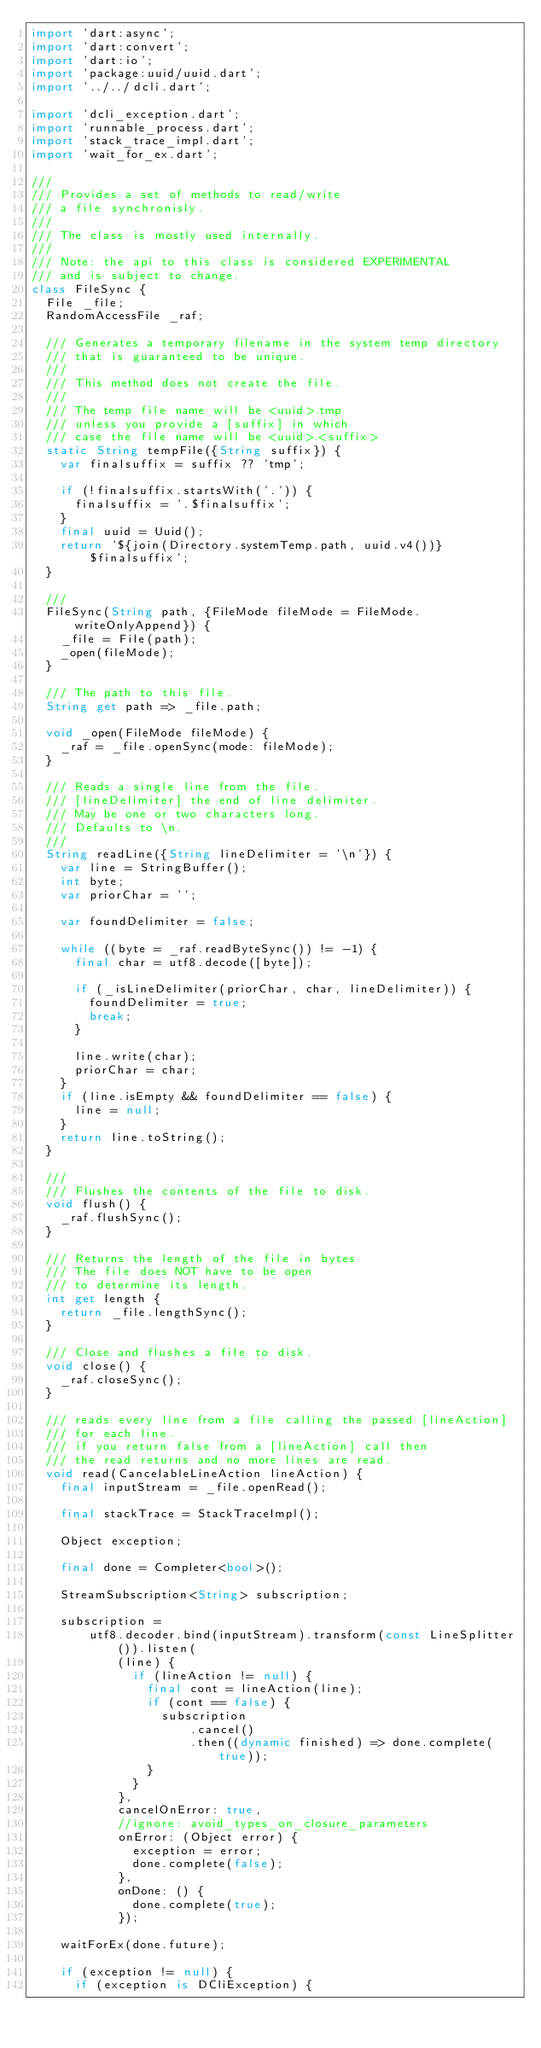<code> <loc_0><loc_0><loc_500><loc_500><_Dart_>import 'dart:async';
import 'dart:convert';
import 'dart:io';
import 'package:uuid/uuid.dart';
import '../../dcli.dart';

import 'dcli_exception.dart';
import 'runnable_process.dart';
import 'stack_trace_impl.dart';
import 'wait_for_ex.dart';

///
/// Provides a set of methods to read/write
/// a file synchronisly.
///
/// The class is mostly used internally.
///
/// Note: the api to this class is considered EXPERIMENTAL
/// and is subject to change.
class FileSync {
  File _file;
  RandomAccessFile _raf;

  /// Generates a temporary filename in the system temp directory
  /// that is guaranteed to be unique.
  ///
  /// This method does not create the file.
  ///
  /// The temp file name will be <uuid>.tmp
  /// unless you provide a [suffix] in which
  /// case the file name will be <uuid>.<suffix>
  static String tempFile({String suffix}) {
    var finalsuffix = suffix ?? 'tmp';

    if (!finalsuffix.startsWith('.')) {
      finalsuffix = '.$finalsuffix';
    }
    final uuid = Uuid();
    return '${join(Directory.systemTemp.path, uuid.v4())}$finalsuffix';
  }

  ///
  FileSync(String path, {FileMode fileMode = FileMode.writeOnlyAppend}) {
    _file = File(path);
    _open(fileMode);
  }

  /// The path to this file.
  String get path => _file.path;

  void _open(FileMode fileMode) {
    _raf = _file.openSync(mode: fileMode);
  }

  /// Reads a single line from the file.
  /// [lineDelimiter] the end of line delimiter.
  /// May be one or two characters long.
  /// Defaults to \n.
  ///
  String readLine({String lineDelimiter = '\n'}) {
    var line = StringBuffer();
    int byte;
    var priorChar = '';

    var foundDelimiter = false;

    while ((byte = _raf.readByteSync()) != -1) {
      final char = utf8.decode([byte]);

      if (_isLineDelimiter(priorChar, char, lineDelimiter)) {
        foundDelimiter = true;
        break;
      }

      line.write(char);
      priorChar = char;
    }
    if (line.isEmpty && foundDelimiter == false) {
      line = null;
    }
    return line.toString();
  }

  ///
  /// Flushes the contents of the file to disk.
  void flush() {
    _raf.flushSync();
  }

  /// Returns the length of the file in bytes
  /// The file does NOT have to be open
  /// to determine its length.
  int get length {
    return _file.lengthSync();
  }

  /// Close and flushes a file to disk.
  void close() {
    _raf.closeSync();
  }

  /// reads every line from a file calling the passed [lineAction]
  /// for each line.
  /// if you return false from a [lineAction] call then
  /// the read returns and no more lines are read.
  void read(CancelableLineAction lineAction) {
    final inputStream = _file.openRead();

    final stackTrace = StackTraceImpl();

    Object exception;

    final done = Completer<bool>();

    StreamSubscription<String> subscription;

    subscription =
        utf8.decoder.bind(inputStream).transform(const LineSplitter()).listen(
            (line) {
              if (lineAction != null) {
                final cont = lineAction(line);
                if (cont == false) {
                  subscription
                      .cancel()
                      .then((dynamic finished) => done.complete(true));
                }
              }
            },
            cancelOnError: true,
            //ignore: avoid_types_on_closure_parameters
            onError: (Object error) {
              exception = error;
              done.complete(false);
            },
            onDone: () {
              done.complete(true);
            });

    waitForEx(done.future);

    if (exception != null) {
      if (exception is DCliException) {</code> 